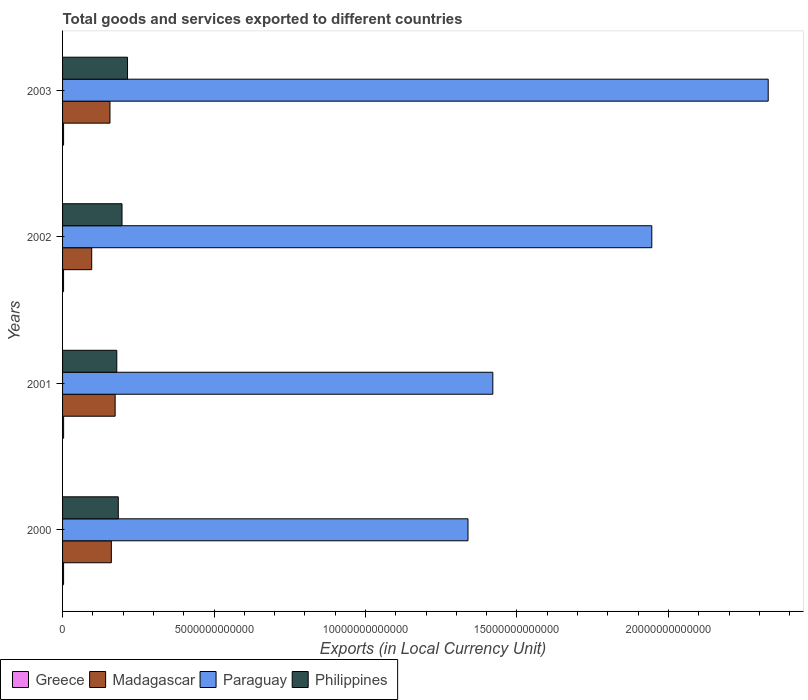How many different coloured bars are there?
Ensure brevity in your answer.  4. Are the number of bars on each tick of the Y-axis equal?
Provide a short and direct response. Yes. How many bars are there on the 3rd tick from the top?
Your response must be concise. 4. How many bars are there on the 2nd tick from the bottom?
Your response must be concise. 4. In how many cases, is the number of bars for a given year not equal to the number of legend labels?
Your response must be concise. 0. What is the Amount of goods and services exports in Greece in 2002?
Make the answer very short. 3.29e+1. Across all years, what is the maximum Amount of goods and services exports in Philippines?
Provide a succinct answer. 2.14e+12. Across all years, what is the minimum Amount of goods and services exports in Greece?
Provide a succinct answer. 3.29e+1. In which year was the Amount of goods and services exports in Philippines maximum?
Offer a terse response. 2003. What is the total Amount of goods and services exports in Madagascar in the graph?
Provide a short and direct response. 5.87e+12. What is the difference between the Amount of goods and services exports in Madagascar in 2001 and that in 2002?
Keep it short and to the point. 7.74e+11. What is the difference between the Amount of goods and services exports in Madagascar in 2000 and the Amount of goods and services exports in Greece in 2002?
Provide a succinct answer. 1.58e+12. What is the average Amount of goods and services exports in Greece per year?
Offer a terse response. 3.36e+1. In the year 2001, what is the difference between the Amount of goods and services exports in Philippines and Amount of goods and services exports in Greece?
Provide a short and direct response. 1.76e+12. What is the ratio of the Amount of goods and services exports in Greece in 2000 to that in 2001?
Make the answer very short. 0.97. Is the Amount of goods and services exports in Madagascar in 2001 less than that in 2002?
Keep it short and to the point. No. Is the difference between the Amount of goods and services exports in Philippines in 2001 and 2002 greater than the difference between the Amount of goods and services exports in Greece in 2001 and 2002?
Provide a short and direct response. No. What is the difference between the highest and the second highest Amount of goods and services exports in Philippines?
Give a very brief answer. 1.82e+11. What is the difference between the highest and the lowest Amount of goods and services exports in Greece?
Keep it short and to the point. 1.81e+09. What does the 2nd bar from the top in 2000 represents?
Ensure brevity in your answer.  Paraguay. What does the 1st bar from the bottom in 2000 represents?
Your response must be concise. Greece. Is it the case that in every year, the sum of the Amount of goods and services exports in Madagascar and Amount of goods and services exports in Greece is greater than the Amount of goods and services exports in Philippines?
Offer a terse response. No. How many bars are there?
Offer a terse response. 16. Are all the bars in the graph horizontal?
Make the answer very short. Yes. What is the difference between two consecutive major ticks on the X-axis?
Your response must be concise. 5.00e+12. Does the graph contain grids?
Make the answer very short. No. Where does the legend appear in the graph?
Offer a very short reply. Bottom left. How many legend labels are there?
Your response must be concise. 4. What is the title of the graph?
Offer a very short reply. Total goods and services exported to different countries. Does "Greece" appear as one of the legend labels in the graph?
Your response must be concise. Yes. What is the label or title of the X-axis?
Give a very brief answer. Exports (in Local Currency Unit). What is the label or title of the Y-axis?
Offer a very short reply. Years. What is the Exports (in Local Currency Unit) in Greece in 2000?
Make the answer very short. 3.35e+1. What is the Exports (in Local Currency Unit) of Madagascar in 2000?
Ensure brevity in your answer.  1.61e+12. What is the Exports (in Local Currency Unit) in Paraguay in 2000?
Offer a terse response. 1.34e+13. What is the Exports (in Local Currency Unit) of Philippines in 2000?
Offer a very short reply. 1.84e+12. What is the Exports (in Local Currency Unit) in Greece in 2001?
Provide a short and direct response. 3.47e+1. What is the Exports (in Local Currency Unit) in Madagascar in 2001?
Offer a terse response. 1.74e+12. What is the Exports (in Local Currency Unit) of Paraguay in 2001?
Ensure brevity in your answer.  1.42e+13. What is the Exports (in Local Currency Unit) in Philippines in 2001?
Ensure brevity in your answer.  1.79e+12. What is the Exports (in Local Currency Unit) of Greece in 2002?
Your response must be concise. 3.29e+1. What is the Exports (in Local Currency Unit) of Madagascar in 2002?
Provide a succinct answer. 9.62e+11. What is the Exports (in Local Currency Unit) of Paraguay in 2002?
Provide a short and direct response. 1.95e+13. What is the Exports (in Local Currency Unit) in Philippines in 2002?
Provide a short and direct response. 1.96e+12. What is the Exports (in Local Currency Unit) of Greece in 2003?
Offer a very short reply. 3.32e+1. What is the Exports (in Local Currency Unit) of Madagascar in 2003?
Provide a short and direct response. 1.56e+12. What is the Exports (in Local Currency Unit) in Paraguay in 2003?
Make the answer very short. 2.33e+13. What is the Exports (in Local Currency Unit) of Philippines in 2003?
Your answer should be very brief. 2.14e+12. Across all years, what is the maximum Exports (in Local Currency Unit) in Greece?
Your answer should be very brief. 3.47e+1. Across all years, what is the maximum Exports (in Local Currency Unit) of Madagascar?
Your answer should be very brief. 1.74e+12. Across all years, what is the maximum Exports (in Local Currency Unit) of Paraguay?
Your answer should be compact. 2.33e+13. Across all years, what is the maximum Exports (in Local Currency Unit) in Philippines?
Your answer should be compact. 2.14e+12. Across all years, what is the minimum Exports (in Local Currency Unit) in Greece?
Offer a terse response. 3.29e+1. Across all years, what is the minimum Exports (in Local Currency Unit) in Madagascar?
Give a very brief answer. 9.62e+11. Across all years, what is the minimum Exports (in Local Currency Unit) of Paraguay?
Provide a short and direct response. 1.34e+13. Across all years, what is the minimum Exports (in Local Currency Unit) in Philippines?
Provide a short and direct response. 1.79e+12. What is the total Exports (in Local Currency Unit) in Greece in the graph?
Your answer should be very brief. 1.34e+11. What is the total Exports (in Local Currency Unit) of Madagascar in the graph?
Give a very brief answer. 5.87e+12. What is the total Exports (in Local Currency Unit) of Paraguay in the graph?
Offer a very short reply. 7.03e+13. What is the total Exports (in Local Currency Unit) in Philippines in the graph?
Ensure brevity in your answer.  7.74e+12. What is the difference between the Exports (in Local Currency Unit) of Greece in 2000 and that in 2001?
Your answer should be compact. -1.18e+09. What is the difference between the Exports (in Local Currency Unit) in Madagascar in 2000 and that in 2001?
Offer a terse response. -1.25e+11. What is the difference between the Exports (in Local Currency Unit) of Paraguay in 2000 and that in 2001?
Your answer should be very brief. -8.20e+11. What is the difference between the Exports (in Local Currency Unit) in Philippines in 2000 and that in 2001?
Your answer should be compact. 4.95e+1. What is the difference between the Exports (in Local Currency Unit) in Greece in 2000 and that in 2002?
Ensure brevity in your answer.  6.25e+08. What is the difference between the Exports (in Local Currency Unit) of Madagascar in 2000 and that in 2002?
Your answer should be compact. 6.48e+11. What is the difference between the Exports (in Local Currency Unit) in Paraguay in 2000 and that in 2002?
Your answer should be compact. -6.07e+12. What is the difference between the Exports (in Local Currency Unit) of Philippines in 2000 and that in 2002?
Offer a terse response. -1.23e+11. What is the difference between the Exports (in Local Currency Unit) in Greece in 2000 and that in 2003?
Your response must be concise. 3.24e+08. What is the difference between the Exports (in Local Currency Unit) in Madagascar in 2000 and that in 2003?
Provide a short and direct response. 4.53e+1. What is the difference between the Exports (in Local Currency Unit) of Paraguay in 2000 and that in 2003?
Your answer should be very brief. -9.91e+12. What is the difference between the Exports (in Local Currency Unit) of Philippines in 2000 and that in 2003?
Ensure brevity in your answer.  -3.05e+11. What is the difference between the Exports (in Local Currency Unit) of Greece in 2001 and that in 2002?
Provide a succinct answer. 1.81e+09. What is the difference between the Exports (in Local Currency Unit) in Madagascar in 2001 and that in 2002?
Ensure brevity in your answer.  7.74e+11. What is the difference between the Exports (in Local Currency Unit) of Paraguay in 2001 and that in 2002?
Keep it short and to the point. -5.25e+12. What is the difference between the Exports (in Local Currency Unit) of Philippines in 2001 and that in 2002?
Ensure brevity in your answer.  -1.73e+11. What is the difference between the Exports (in Local Currency Unit) in Greece in 2001 and that in 2003?
Ensure brevity in your answer.  1.51e+09. What is the difference between the Exports (in Local Currency Unit) in Madagascar in 2001 and that in 2003?
Ensure brevity in your answer.  1.71e+11. What is the difference between the Exports (in Local Currency Unit) of Paraguay in 2001 and that in 2003?
Your answer should be compact. -9.09e+12. What is the difference between the Exports (in Local Currency Unit) of Philippines in 2001 and that in 2003?
Provide a short and direct response. -3.55e+11. What is the difference between the Exports (in Local Currency Unit) of Greece in 2002 and that in 2003?
Your response must be concise. -3.01e+08. What is the difference between the Exports (in Local Currency Unit) in Madagascar in 2002 and that in 2003?
Provide a short and direct response. -6.03e+11. What is the difference between the Exports (in Local Currency Unit) of Paraguay in 2002 and that in 2003?
Provide a short and direct response. -3.84e+12. What is the difference between the Exports (in Local Currency Unit) in Philippines in 2002 and that in 2003?
Your answer should be compact. -1.82e+11. What is the difference between the Exports (in Local Currency Unit) of Greece in 2000 and the Exports (in Local Currency Unit) of Madagascar in 2001?
Provide a short and direct response. -1.70e+12. What is the difference between the Exports (in Local Currency Unit) of Greece in 2000 and the Exports (in Local Currency Unit) of Paraguay in 2001?
Make the answer very short. -1.42e+13. What is the difference between the Exports (in Local Currency Unit) of Greece in 2000 and the Exports (in Local Currency Unit) of Philippines in 2001?
Offer a terse response. -1.76e+12. What is the difference between the Exports (in Local Currency Unit) of Madagascar in 2000 and the Exports (in Local Currency Unit) of Paraguay in 2001?
Your response must be concise. -1.26e+13. What is the difference between the Exports (in Local Currency Unit) in Madagascar in 2000 and the Exports (in Local Currency Unit) in Philippines in 2001?
Make the answer very short. -1.80e+11. What is the difference between the Exports (in Local Currency Unit) in Paraguay in 2000 and the Exports (in Local Currency Unit) in Philippines in 2001?
Your response must be concise. 1.16e+13. What is the difference between the Exports (in Local Currency Unit) of Greece in 2000 and the Exports (in Local Currency Unit) of Madagascar in 2002?
Make the answer very short. -9.28e+11. What is the difference between the Exports (in Local Currency Unit) of Greece in 2000 and the Exports (in Local Currency Unit) of Paraguay in 2002?
Ensure brevity in your answer.  -1.94e+13. What is the difference between the Exports (in Local Currency Unit) in Greece in 2000 and the Exports (in Local Currency Unit) in Philippines in 2002?
Ensure brevity in your answer.  -1.93e+12. What is the difference between the Exports (in Local Currency Unit) in Madagascar in 2000 and the Exports (in Local Currency Unit) in Paraguay in 2002?
Offer a very short reply. -1.78e+13. What is the difference between the Exports (in Local Currency Unit) of Madagascar in 2000 and the Exports (in Local Currency Unit) of Philippines in 2002?
Provide a succinct answer. -3.52e+11. What is the difference between the Exports (in Local Currency Unit) of Paraguay in 2000 and the Exports (in Local Currency Unit) of Philippines in 2002?
Your answer should be very brief. 1.14e+13. What is the difference between the Exports (in Local Currency Unit) in Greece in 2000 and the Exports (in Local Currency Unit) in Madagascar in 2003?
Your answer should be compact. -1.53e+12. What is the difference between the Exports (in Local Currency Unit) of Greece in 2000 and the Exports (in Local Currency Unit) of Paraguay in 2003?
Your response must be concise. -2.33e+13. What is the difference between the Exports (in Local Currency Unit) in Greece in 2000 and the Exports (in Local Currency Unit) in Philippines in 2003?
Offer a terse response. -2.11e+12. What is the difference between the Exports (in Local Currency Unit) of Madagascar in 2000 and the Exports (in Local Currency Unit) of Paraguay in 2003?
Provide a succinct answer. -2.17e+13. What is the difference between the Exports (in Local Currency Unit) in Madagascar in 2000 and the Exports (in Local Currency Unit) in Philippines in 2003?
Your answer should be very brief. -5.35e+11. What is the difference between the Exports (in Local Currency Unit) of Paraguay in 2000 and the Exports (in Local Currency Unit) of Philippines in 2003?
Your answer should be very brief. 1.12e+13. What is the difference between the Exports (in Local Currency Unit) of Greece in 2001 and the Exports (in Local Currency Unit) of Madagascar in 2002?
Make the answer very short. -9.27e+11. What is the difference between the Exports (in Local Currency Unit) of Greece in 2001 and the Exports (in Local Currency Unit) of Paraguay in 2002?
Ensure brevity in your answer.  -1.94e+13. What is the difference between the Exports (in Local Currency Unit) in Greece in 2001 and the Exports (in Local Currency Unit) in Philippines in 2002?
Ensure brevity in your answer.  -1.93e+12. What is the difference between the Exports (in Local Currency Unit) in Madagascar in 2001 and the Exports (in Local Currency Unit) in Paraguay in 2002?
Keep it short and to the point. -1.77e+13. What is the difference between the Exports (in Local Currency Unit) in Madagascar in 2001 and the Exports (in Local Currency Unit) in Philippines in 2002?
Your response must be concise. -2.27e+11. What is the difference between the Exports (in Local Currency Unit) of Paraguay in 2001 and the Exports (in Local Currency Unit) of Philippines in 2002?
Provide a short and direct response. 1.22e+13. What is the difference between the Exports (in Local Currency Unit) of Greece in 2001 and the Exports (in Local Currency Unit) of Madagascar in 2003?
Provide a short and direct response. -1.53e+12. What is the difference between the Exports (in Local Currency Unit) in Greece in 2001 and the Exports (in Local Currency Unit) in Paraguay in 2003?
Offer a terse response. -2.33e+13. What is the difference between the Exports (in Local Currency Unit) in Greece in 2001 and the Exports (in Local Currency Unit) in Philippines in 2003?
Your response must be concise. -2.11e+12. What is the difference between the Exports (in Local Currency Unit) of Madagascar in 2001 and the Exports (in Local Currency Unit) of Paraguay in 2003?
Offer a very short reply. -2.16e+13. What is the difference between the Exports (in Local Currency Unit) of Madagascar in 2001 and the Exports (in Local Currency Unit) of Philippines in 2003?
Ensure brevity in your answer.  -4.09e+11. What is the difference between the Exports (in Local Currency Unit) in Paraguay in 2001 and the Exports (in Local Currency Unit) in Philippines in 2003?
Make the answer very short. 1.21e+13. What is the difference between the Exports (in Local Currency Unit) in Greece in 2002 and the Exports (in Local Currency Unit) in Madagascar in 2003?
Ensure brevity in your answer.  -1.53e+12. What is the difference between the Exports (in Local Currency Unit) of Greece in 2002 and the Exports (in Local Currency Unit) of Paraguay in 2003?
Give a very brief answer. -2.33e+13. What is the difference between the Exports (in Local Currency Unit) of Greece in 2002 and the Exports (in Local Currency Unit) of Philippines in 2003?
Make the answer very short. -2.11e+12. What is the difference between the Exports (in Local Currency Unit) of Madagascar in 2002 and the Exports (in Local Currency Unit) of Paraguay in 2003?
Provide a short and direct response. -2.23e+13. What is the difference between the Exports (in Local Currency Unit) in Madagascar in 2002 and the Exports (in Local Currency Unit) in Philippines in 2003?
Provide a succinct answer. -1.18e+12. What is the difference between the Exports (in Local Currency Unit) in Paraguay in 2002 and the Exports (in Local Currency Unit) in Philippines in 2003?
Your answer should be very brief. 1.73e+13. What is the average Exports (in Local Currency Unit) in Greece per year?
Your answer should be compact. 3.36e+1. What is the average Exports (in Local Currency Unit) in Madagascar per year?
Keep it short and to the point. 1.47e+12. What is the average Exports (in Local Currency Unit) of Paraguay per year?
Provide a short and direct response. 1.76e+13. What is the average Exports (in Local Currency Unit) in Philippines per year?
Provide a short and direct response. 1.93e+12. In the year 2000, what is the difference between the Exports (in Local Currency Unit) of Greece and Exports (in Local Currency Unit) of Madagascar?
Give a very brief answer. -1.58e+12. In the year 2000, what is the difference between the Exports (in Local Currency Unit) in Greece and Exports (in Local Currency Unit) in Paraguay?
Keep it short and to the point. -1.34e+13. In the year 2000, what is the difference between the Exports (in Local Currency Unit) of Greece and Exports (in Local Currency Unit) of Philippines?
Keep it short and to the point. -1.81e+12. In the year 2000, what is the difference between the Exports (in Local Currency Unit) in Madagascar and Exports (in Local Currency Unit) in Paraguay?
Your answer should be compact. -1.18e+13. In the year 2000, what is the difference between the Exports (in Local Currency Unit) of Madagascar and Exports (in Local Currency Unit) of Philippines?
Your answer should be compact. -2.29e+11. In the year 2000, what is the difference between the Exports (in Local Currency Unit) of Paraguay and Exports (in Local Currency Unit) of Philippines?
Provide a short and direct response. 1.15e+13. In the year 2001, what is the difference between the Exports (in Local Currency Unit) in Greece and Exports (in Local Currency Unit) in Madagascar?
Your answer should be compact. -1.70e+12. In the year 2001, what is the difference between the Exports (in Local Currency Unit) of Greece and Exports (in Local Currency Unit) of Paraguay?
Offer a very short reply. -1.42e+13. In the year 2001, what is the difference between the Exports (in Local Currency Unit) in Greece and Exports (in Local Currency Unit) in Philippines?
Give a very brief answer. -1.76e+12. In the year 2001, what is the difference between the Exports (in Local Currency Unit) of Madagascar and Exports (in Local Currency Unit) of Paraguay?
Make the answer very short. -1.25e+13. In the year 2001, what is the difference between the Exports (in Local Currency Unit) in Madagascar and Exports (in Local Currency Unit) in Philippines?
Make the answer very short. -5.43e+1. In the year 2001, what is the difference between the Exports (in Local Currency Unit) of Paraguay and Exports (in Local Currency Unit) of Philippines?
Make the answer very short. 1.24e+13. In the year 2002, what is the difference between the Exports (in Local Currency Unit) in Greece and Exports (in Local Currency Unit) in Madagascar?
Offer a terse response. -9.29e+11. In the year 2002, what is the difference between the Exports (in Local Currency Unit) of Greece and Exports (in Local Currency Unit) of Paraguay?
Give a very brief answer. -1.94e+13. In the year 2002, what is the difference between the Exports (in Local Currency Unit) in Greece and Exports (in Local Currency Unit) in Philippines?
Offer a very short reply. -1.93e+12. In the year 2002, what is the difference between the Exports (in Local Currency Unit) in Madagascar and Exports (in Local Currency Unit) in Paraguay?
Ensure brevity in your answer.  -1.85e+13. In the year 2002, what is the difference between the Exports (in Local Currency Unit) in Madagascar and Exports (in Local Currency Unit) in Philippines?
Give a very brief answer. -1.00e+12. In the year 2002, what is the difference between the Exports (in Local Currency Unit) in Paraguay and Exports (in Local Currency Unit) in Philippines?
Make the answer very short. 1.75e+13. In the year 2003, what is the difference between the Exports (in Local Currency Unit) of Greece and Exports (in Local Currency Unit) of Madagascar?
Provide a succinct answer. -1.53e+12. In the year 2003, what is the difference between the Exports (in Local Currency Unit) in Greece and Exports (in Local Currency Unit) in Paraguay?
Ensure brevity in your answer.  -2.33e+13. In the year 2003, what is the difference between the Exports (in Local Currency Unit) of Greece and Exports (in Local Currency Unit) of Philippines?
Give a very brief answer. -2.11e+12. In the year 2003, what is the difference between the Exports (in Local Currency Unit) of Madagascar and Exports (in Local Currency Unit) of Paraguay?
Provide a succinct answer. -2.17e+13. In the year 2003, what is the difference between the Exports (in Local Currency Unit) of Madagascar and Exports (in Local Currency Unit) of Philippines?
Offer a terse response. -5.80e+11. In the year 2003, what is the difference between the Exports (in Local Currency Unit) in Paraguay and Exports (in Local Currency Unit) in Philippines?
Your response must be concise. 2.11e+13. What is the ratio of the Exports (in Local Currency Unit) of Greece in 2000 to that in 2001?
Offer a very short reply. 0.97. What is the ratio of the Exports (in Local Currency Unit) of Madagascar in 2000 to that in 2001?
Ensure brevity in your answer.  0.93. What is the ratio of the Exports (in Local Currency Unit) of Paraguay in 2000 to that in 2001?
Make the answer very short. 0.94. What is the ratio of the Exports (in Local Currency Unit) in Philippines in 2000 to that in 2001?
Give a very brief answer. 1.03. What is the ratio of the Exports (in Local Currency Unit) of Greece in 2000 to that in 2002?
Provide a short and direct response. 1.02. What is the ratio of the Exports (in Local Currency Unit) of Madagascar in 2000 to that in 2002?
Your response must be concise. 1.67. What is the ratio of the Exports (in Local Currency Unit) of Paraguay in 2000 to that in 2002?
Offer a very short reply. 0.69. What is the ratio of the Exports (in Local Currency Unit) in Philippines in 2000 to that in 2002?
Ensure brevity in your answer.  0.94. What is the ratio of the Exports (in Local Currency Unit) in Greece in 2000 to that in 2003?
Provide a succinct answer. 1.01. What is the ratio of the Exports (in Local Currency Unit) of Madagascar in 2000 to that in 2003?
Keep it short and to the point. 1.03. What is the ratio of the Exports (in Local Currency Unit) of Paraguay in 2000 to that in 2003?
Make the answer very short. 0.57. What is the ratio of the Exports (in Local Currency Unit) in Philippines in 2000 to that in 2003?
Your answer should be compact. 0.86. What is the ratio of the Exports (in Local Currency Unit) of Greece in 2001 to that in 2002?
Provide a short and direct response. 1.05. What is the ratio of the Exports (in Local Currency Unit) in Madagascar in 2001 to that in 2002?
Provide a short and direct response. 1.8. What is the ratio of the Exports (in Local Currency Unit) of Paraguay in 2001 to that in 2002?
Your answer should be compact. 0.73. What is the ratio of the Exports (in Local Currency Unit) in Philippines in 2001 to that in 2002?
Provide a short and direct response. 0.91. What is the ratio of the Exports (in Local Currency Unit) of Greece in 2001 to that in 2003?
Keep it short and to the point. 1.05. What is the ratio of the Exports (in Local Currency Unit) in Madagascar in 2001 to that in 2003?
Your response must be concise. 1.11. What is the ratio of the Exports (in Local Currency Unit) of Paraguay in 2001 to that in 2003?
Offer a very short reply. 0.61. What is the ratio of the Exports (in Local Currency Unit) of Philippines in 2001 to that in 2003?
Make the answer very short. 0.83. What is the ratio of the Exports (in Local Currency Unit) of Greece in 2002 to that in 2003?
Offer a terse response. 0.99. What is the ratio of the Exports (in Local Currency Unit) of Madagascar in 2002 to that in 2003?
Give a very brief answer. 0.61. What is the ratio of the Exports (in Local Currency Unit) in Paraguay in 2002 to that in 2003?
Your answer should be very brief. 0.83. What is the ratio of the Exports (in Local Currency Unit) in Philippines in 2002 to that in 2003?
Keep it short and to the point. 0.92. What is the difference between the highest and the second highest Exports (in Local Currency Unit) of Greece?
Offer a very short reply. 1.18e+09. What is the difference between the highest and the second highest Exports (in Local Currency Unit) of Madagascar?
Your answer should be compact. 1.25e+11. What is the difference between the highest and the second highest Exports (in Local Currency Unit) in Paraguay?
Your answer should be compact. 3.84e+12. What is the difference between the highest and the second highest Exports (in Local Currency Unit) in Philippines?
Offer a very short reply. 1.82e+11. What is the difference between the highest and the lowest Exports (in Local Currency Unit) of Greece?
Ensure brevity in your answer.  1.81e+09. What is the difference between the highest and the lowest Exports (in Local Currency Unit) of Madagascar?
Offer a very short reply. 7.74e+11. What is the difference between the highest and the lowest Exports (in Local Currency Unit) of Paraguay?
Your answer should be very brief. 9.91e+12. What is the difference between the highest and the lowest Exports (in Local Currency Unit) in Philippines?
Ensure brevity in your answer.  3.55e+11. 